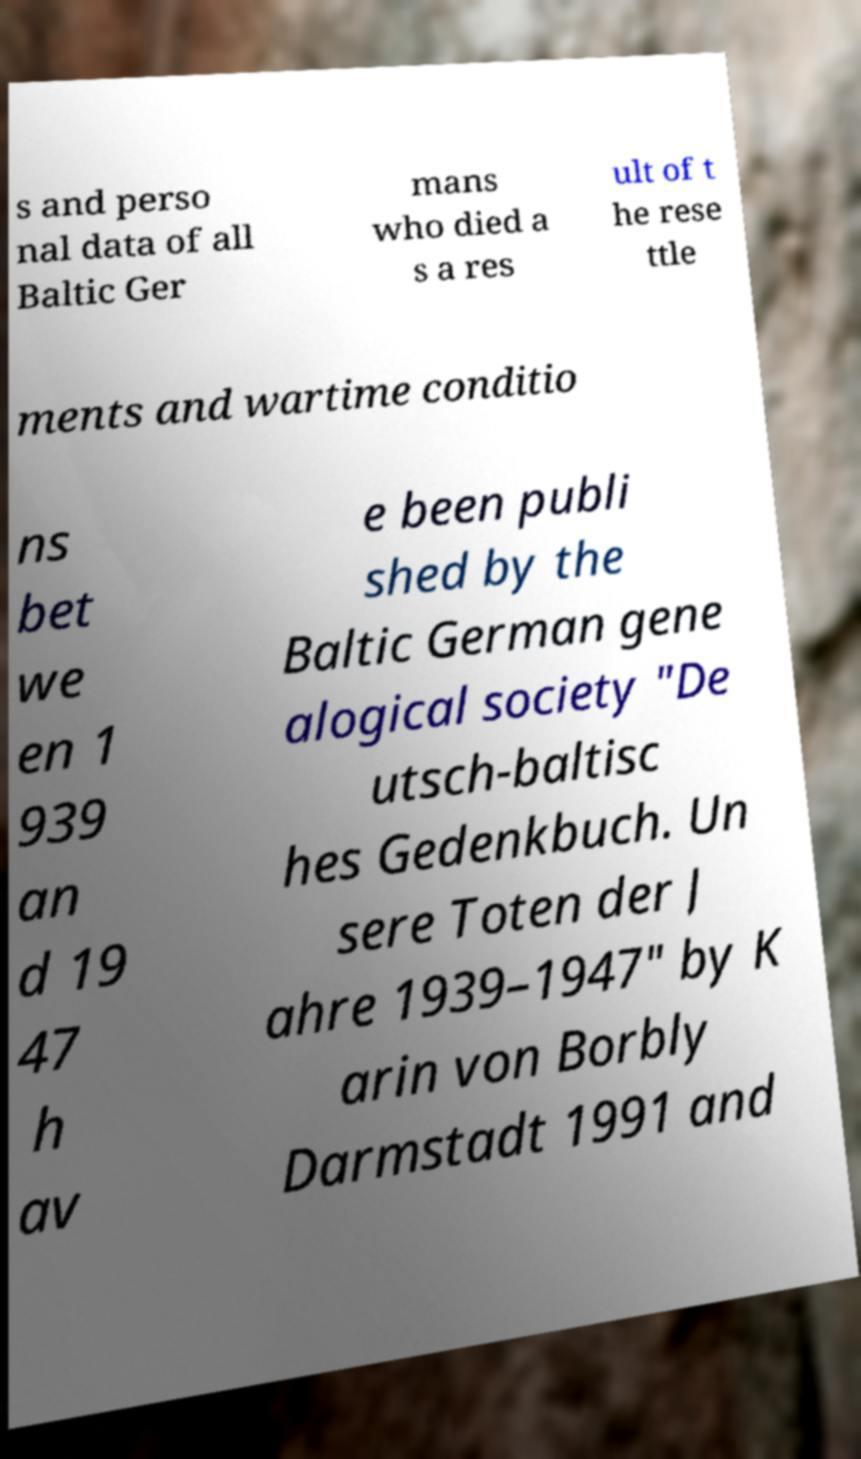I need the written content from this picture converted into text. Can you do that? s and perso nal data of all Baltic Ger mans who died a s a res ult of t he rese ttle ments and wartime conditio ns bet we en 1 939 an d 19 47 h av e been publi shed by the Baltic German gene alogical society "De utsch-baltisc hes Gedenkbuch. Un sere Toten der J ahre 1939–1947" by K arin von Borbly Darmstadt 1991 and 